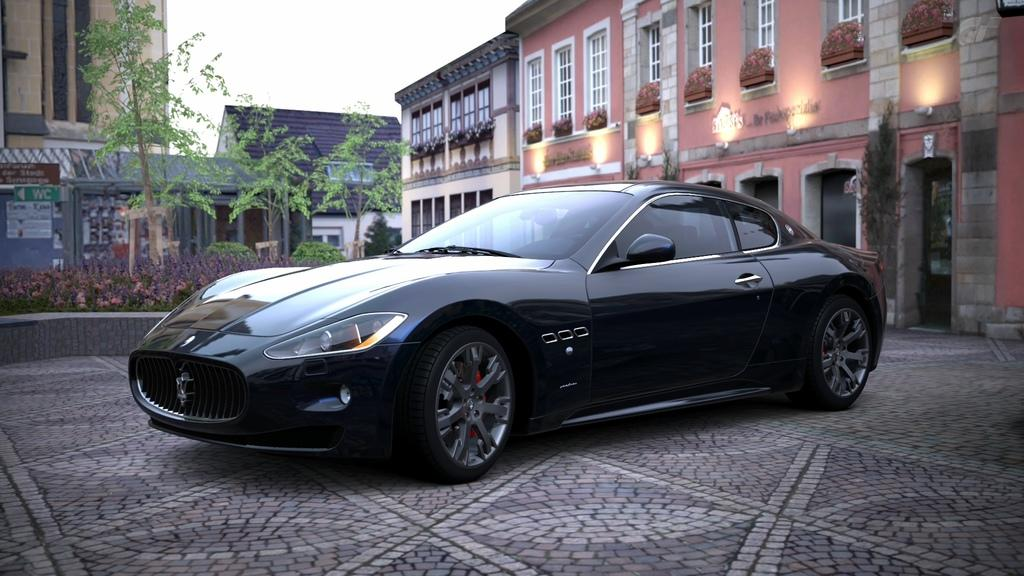What type of vehicle is on the floor in the image? There is a black color vehicle on the floor. What can be seen in the background of the image? There are trees, plants, buildings with windows, and the sky visible in the background. Can you describe the buildings in the background? The buildings in the background have windows. How many beds can be seen in the image? There are no beds present in the image. What type of rock is visible in the image? There is no rock visible in the image. 